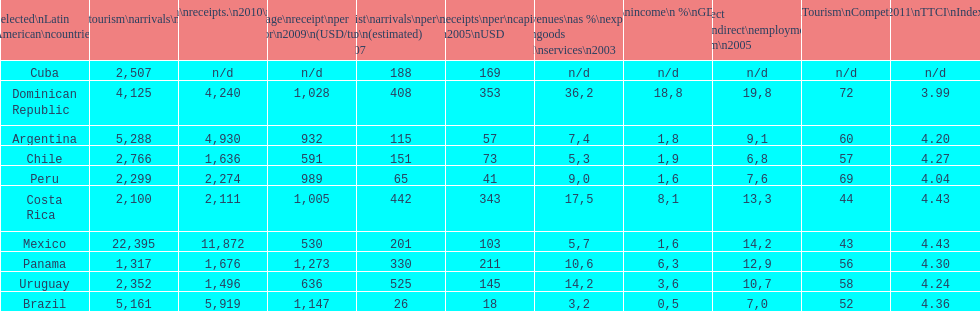What country had the least arrivals per 1000 inhabitants in 2007(estimated)? Brazil. 